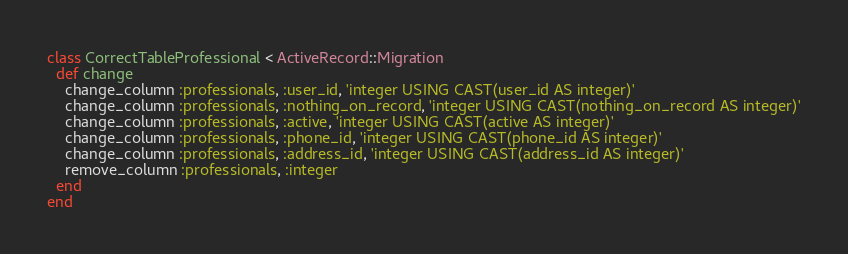<code> <loc_0><loc_0><loc_500><loc_500><_Ruby_>class CorrectTableProfessional < ActiveRecord::Migration
  def change
	change_column :professionals, :user_id, 'integer USING CAST(user_id AS integer)'
	change_column :professionals, :nothing_on_record, 'integer USING CAST(nothing_on_record AS integer)'
	change_column :professionals, :active, 'integer USING CAST(active AS integer)'
	change_column :professionals, :phone_id, 'integer USING CAST(phone_id AS integer)'
	change_column :professionals, :address_id, 'integer USING CAST(address_id AS integer)'
	remove_column :professionals, :integer
  end
end
</code> 